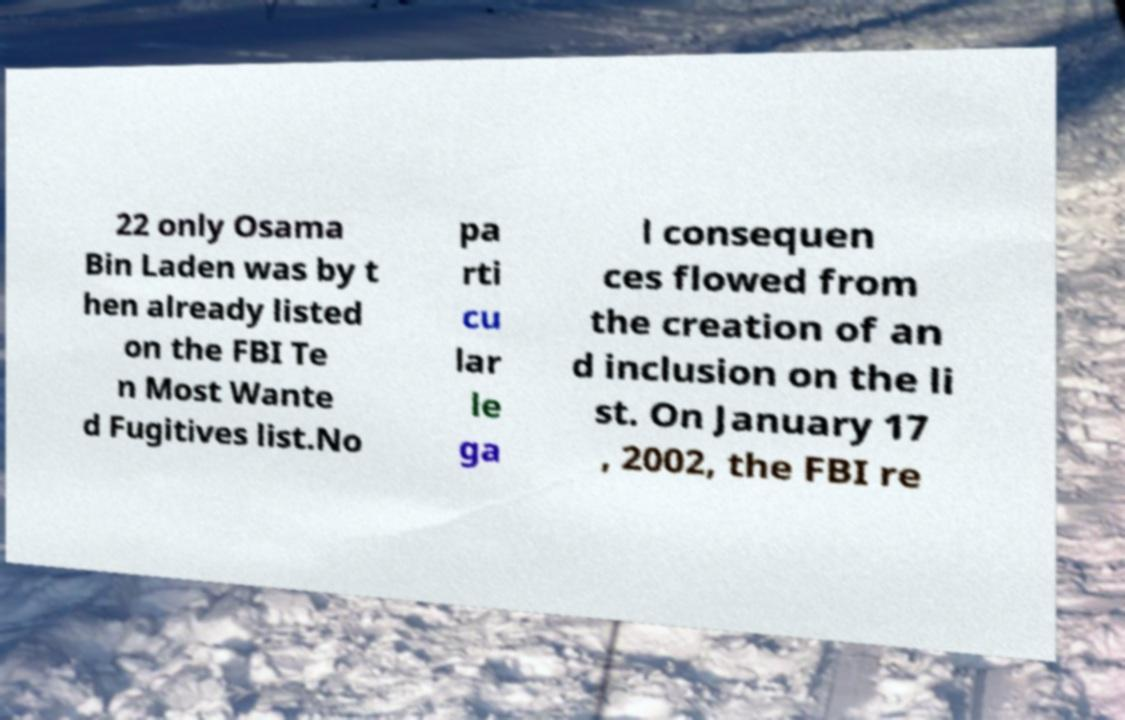Could you extract and type out the text from this image? 22 only Osama Bin Laden was by t hen already listed on the FBI Te n Most Wante d Fugitives list.No pa rti cu lar le ga l consequen ces flowed from the creation of an d inclusion on the li st. On January 17 , 2002, the FBI re 